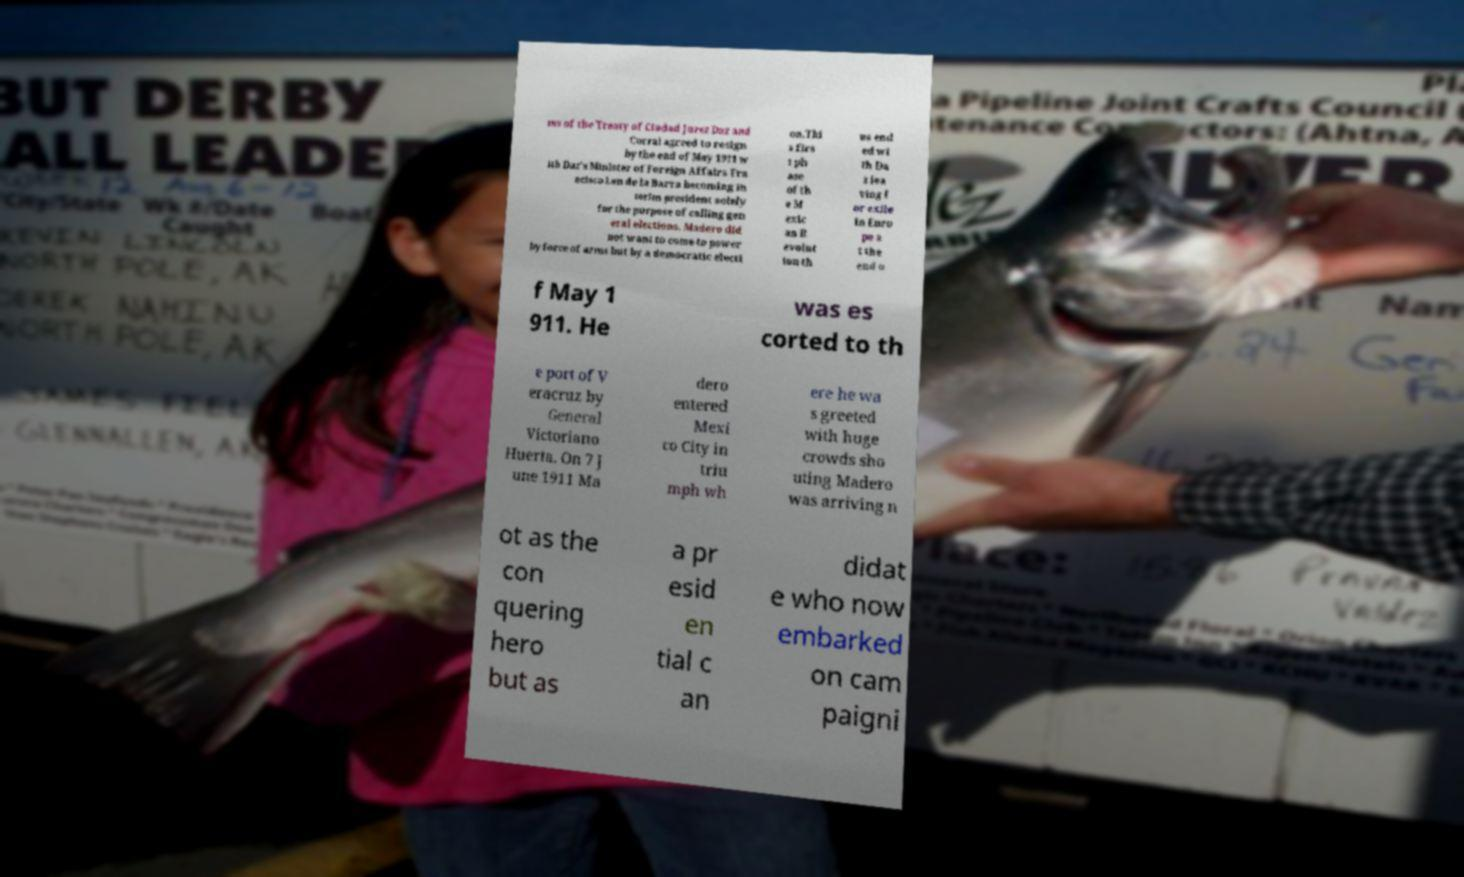Please read and relay the text visible in this image. What does it say? ms of the Treaty of Ciudad Jurez Daz and Corral agreed to resign by the end of May 1911 w ith Daz's Minister of Foreign Affairs Fra ncisco Len de la Barra becoming in terim president solely for the purpose of calling gen eral elections. Madero did not want to come to power by force of arms but by a democratic electi on.Thi s firs t ph ase of th e M exic an R evolut ion th us end ed wi th Da z lea ving f or exile in Euro pe a t the end o f May 1 911. He was es corted to th e port of V eracruz by General Victoriano Huerta. On 7 J une 1911 Ma dero entered Mexi co City in triu mph wh ere he wa s greeted with huge crowds sho uting Madero was arriving n ot as the con quering hero but as a pr esid en tial c an didat e who now embarked on cam paigni 